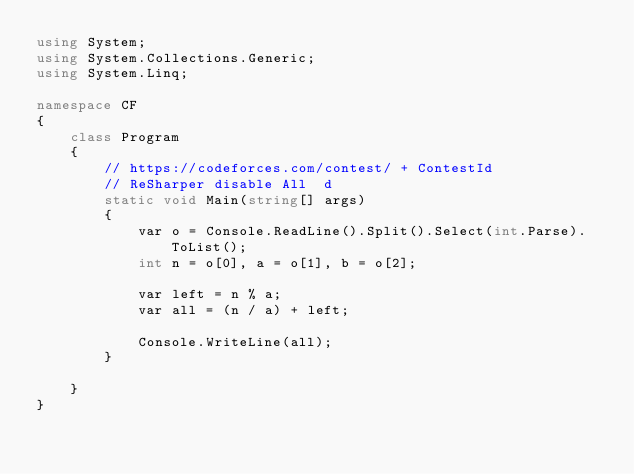Convert code to text. <code><loc_0><loc_0><loc_500><loc_500><_C#_>using System;
using System.Collections.Generic;
using System.Linq;

namespace CF
{
    class Program
    {
        // https://codeforces.com/contest/ + ContestId
        // ReSharper disable All  d 
        static void Main(string[] args)
        {
            var o = Console.ReadLine().Split().Select(int.Parse).ToList();
            int n = o[0], a = o[1], b = o[2];

            var left = n % a;
            var all = (n / a) + left;

            Console.WriteLine(all);
        }

    }
}



</code> 